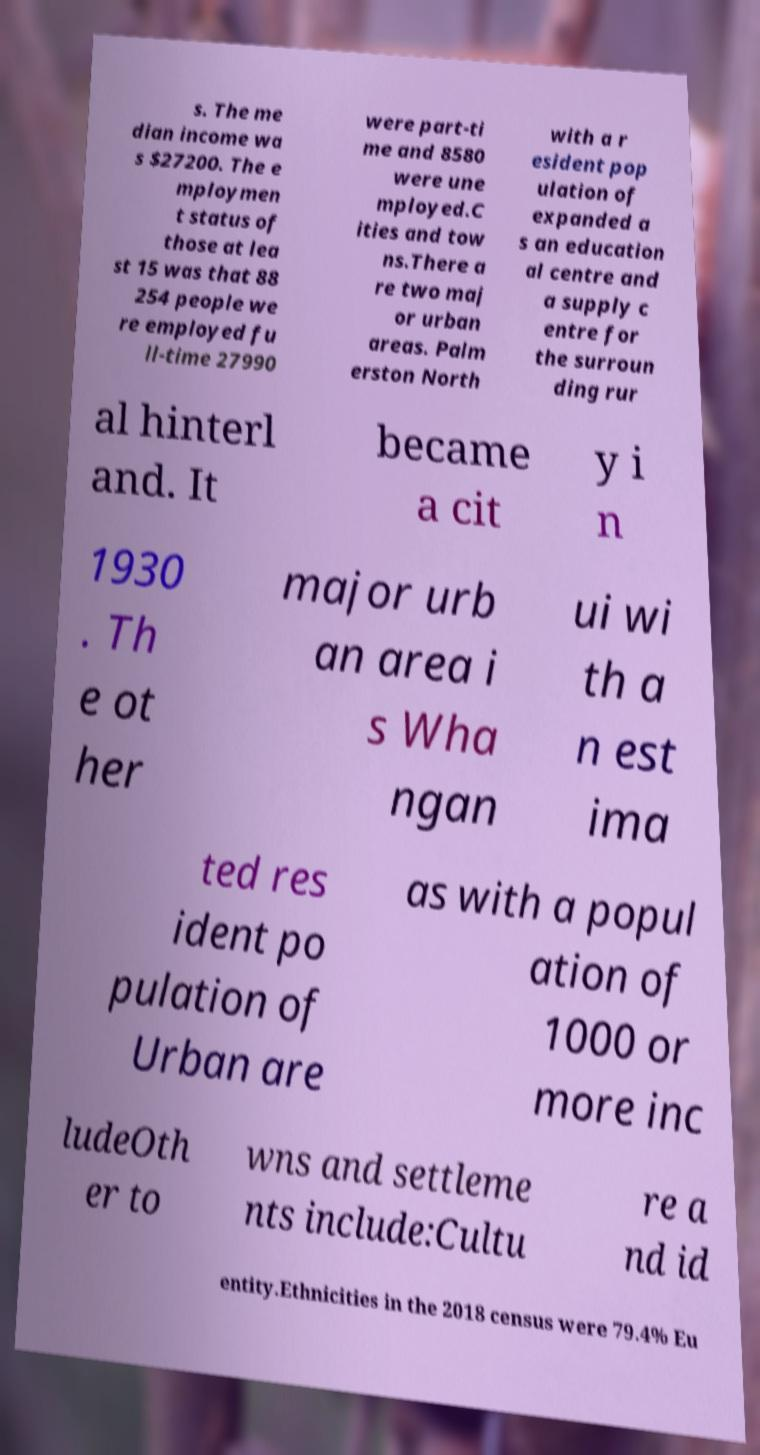I need the written content from this picture converted into text. Can you do that? s. The me dian income wa s $27200. The e mploymen t status of those at lea st 15 was that 88 254 people we re employed fu ll-time 27990 were part-ti me and 8580 were une mployed.C ities and tow ns.There a re two maj or urban areas. Palm erston North with a r esident pop ulation of expanded a s an education al centre and a supply c entre for the surroun ding rur al hinterl and. It became a cit y i n 1930 . Th e ot her major urb an area i s Wha ngan ui wi th a n est ima ted res ident po pulation of Urban are as with a popul ation of 1000 or more inc ludeOth er to wns and settleme nts include:Cultu re a nd id entity.Ethnicities in the 2018 census were 79.4% Eu 